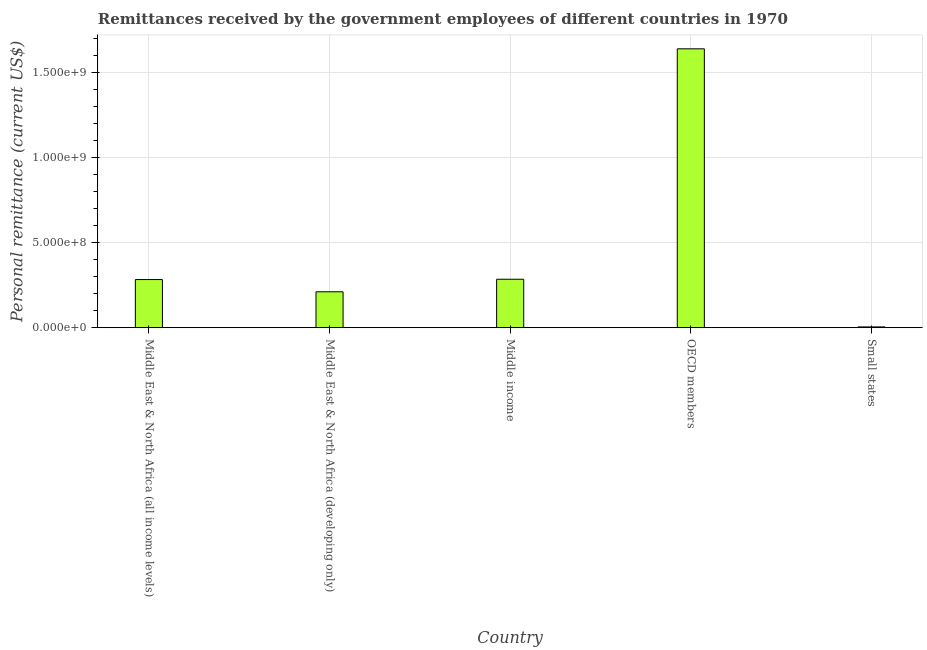What is the title of the graph?
Give a very brief answer. Remittances received by the government employees of different countries in 1970. What is the label or title of the X-axis?
Offer a terse response. Country. What is the label or title of the Y-axis?
Your response must be concise. Personal remittance (current US$). What is the personal remittances in Middle East & North Africa (developing only)?
Ensure brevity in your answer.  2.11e+08. Across all countries, what is the maximum personal remittances?
Give a very brief answer. 1.64e+09. Across all countries, what is the minimum personal remittances?
Give a very brief answer. 4.40e+06. In which country was the personal remittances minimum?
Keep it short and to the point. Small states. What is the sum of the personal remittances?
Your answer should be compact. 2.42e+09. What is the difference between the personal remittances in Middle income and OECD members?
Your answer should be compact. -1.36e+09. What is the average personal remittances per country?
Keep it short and to the point. 4.85e+08. What is the median personal remittances?
Offer a very short reply. 2.83e+08. In how many countries, is the personal remittances greater than 900000000 US$?
Your response must be concise. 1. What is the ratio of the personal remittances in Middle East & North Africa (all income levels) to that in Middle income?
Ensure brevity in your answer.  0.99. Is the personal remittances in Middle East & North Africa (all income levels) less than that in Middle income?
Offer a terse response. Yes. Is the difference between the personal remittances in Middle East & North Africa (developing only) and OECD members greater than the difference between any two countries?
Your answer should be very brief. No. What is the difference between the highest and the second highest personal remittances?
Provide a succinct answer. 1.36e+09. What is the difference between the highest and the lowest personal remittances?
Offer a very short reply. 1.64e+09. In how many countries, is the personal remittances greater than the average personal remittances taken over all countries?
Ensure brevity in your answer.  1. How many countries are there in the graph?
Provide a succinct answer. 5. What is the difference between two consecutive major ticks on the Y-axis?
Your answer should be compact. 5.00e+08. Are the values on the major ticks of Y-axis written in scientific E-notation?
Your response must be concise. Yes. What is the Personal remittance (current US$) of Middle East & North Africa (all income levels)?
Make the answer very short. 2.83e+08. What is the Personal remittance (current US$) of Middle East & North Africa (developing only)?
Ensure brevity in your answer.  2.11e+08. What is the Personal remittance (current US$) of Middle income?
Provide a succinct answer. 2.85e+08. What is the Personal remittance (current US$) in OECD members?
Provide a succinct answer. 1.64e+09. What is the Personal remittance (current US$) in Small states?
Provide a succinct answer. 4.40e+06. What is the difference between the Personal remittance (current US$) in Middle East & North Africa (all income levels) and Middle East & North Africa (developing only)?
Provide a succinct answer. 7.20e+07. What is the difference between the Personal remittance (current US$) in Middle East & North Africa (all income levels) and Middle income?
Keep it short and to the point. -1.76e+06. What is the difference between the Personal remittance (current US$) in Middle East & North Africa (all income levels) and OECD members?
Your answer should be compact. -1.36e+09. What is the difference between the Personal remittance (current US$) in Middle East & North Africa (all income levels) and Small states?
Keep it short and to the point. 2.79e+08. What is the difference between the Personal remittance (current US$) in Middle East & North Africa (developing only) and Middle income?
Ensure brevity in your answer.  -7.38e+07. What is the difference between the Personal remittance (current US$) in Middle East & North Africa (developing only) and OECD members?
Your response must be concise. -1.43e+09. What is the difference between the Personal remittance (current US$) in Middle East & North Africa (developing only) and Small states?
Offer a terse response. 2.07e+08. What is the difference between the Personal remittance (current US$) in Middle income and OECD members?
Offer a very short reply. -1.36e+09. What is the difference between the Personal remittance (current US$) in Middle income and Small states?
Your answer should be very brief. 2.80e+08. What is the difference between the Personal remittance (current US$) in OECD members and Small states?
Provide a short and direct response. 1.64e+09. What is the ratio of the Personal remittance (current US$) in Middle East & North Africa (all income levels) to that in Middle East & North Africa (developing only)?
Your answer should be compact. 1.34. What is the ratio of the Personal remittance (current US$) in Middle East & North Africa (all income levels) to that in Middle income?
Your answer should be very brief. 0.99. What is the ratio of the Personal remittance (current US$) in Middle East & North Africa (all income levels) to that in OECD members?
Your answer should be very brief. 0.17. What is the ratio of the Personal remittance (current US$) in Middle East & North Africa (all income levels) to that in Small states?
Your answer should be very brief. 64.32. What is the ratio of the Personal remittance (current US$) in Middle East & North Africa (developing only) to that in Middle income?
Provide a succinct answer. 0.74. What is the ratio of the Personal remittance (current US$) in Middle East & North Africa (developing only) to that in OECD members?
Ensure brevity in your answer.  0.13. What is the ratio of the Personal remittance (current US$) in Middle East & North Africa (developing only) to that in Small states?
Keep it short and to the point. 47.95. What is the ratio of the Personal remittance (current US$) in Middle income to that in OECD members?
Your answer should be very brief. 0.17. What is the ratio of the Personal remittance (current US$) in Middle income to that in Small states?
Ensure brevity in your answer.  64.72. What is the ratio of the Personal remittance (current US$) in OECD members to that in Small states?
Provide a short and direct response. 372.75. 